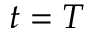<formula> <loc_0><loc_0><loc_500><loc_500>t = T</formula> 